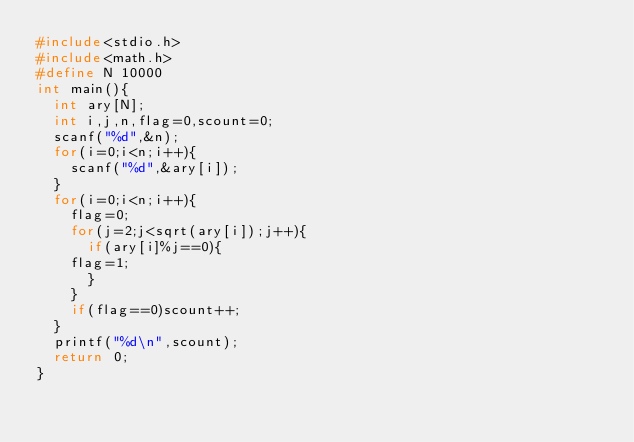<code> <loc_0><loc_0><loc_500><loc_500><_C_>#include<stdio.h>
#include<math.h>
#define N 10000
int main(){
  int ary[N];
  int i,j,n,flag=0,scount=0;
  scanf("%d",&n);
  for(i=0;i<n;i++){
    scanf("%d",&ary[i]);
  }
  for(i=0;i<n;i++){
    flag=0;
    for(j=2;j<sqrt(ary[i]);j++){
      if(ary[i]%j==0){
	flag=1;
      }
    }
    if(flag==0)scount++;
  }
  printf("%d\n",scount);
  return 0;
}

</code> 